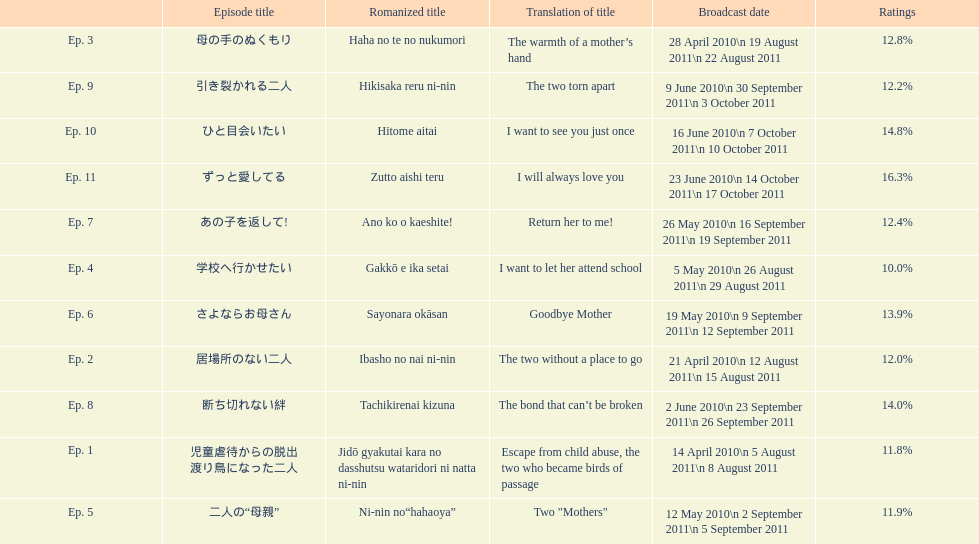How many episodes were broadcast in april 2010 in japan? 3. 